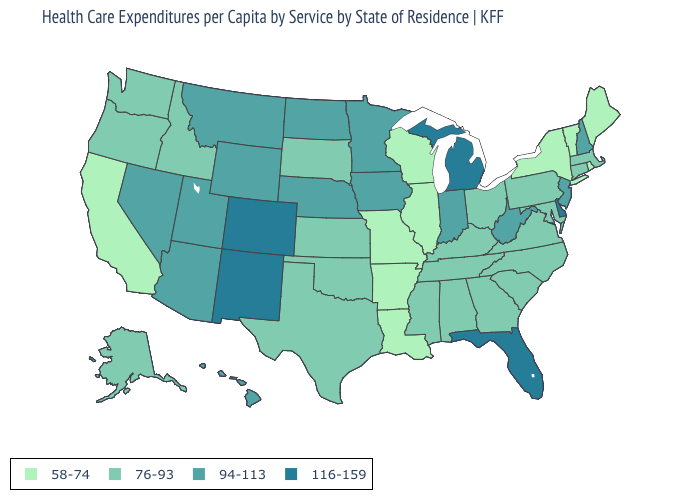Does the map have missing data?
Give a very brief answer. No. Which states have the lowest value in the MidWest?
Short answer required. Illinois, Missouri, Wisconsin. Which states have the highest value in the USA?
Give a very brief answer. Colorado, Delaware, Florida, Michigan, New Mexico. Does New York have the same value as Vermont?
Concise answer only. Yes. Among the states that border Alabama , does Mississippi have the lowest value?
Be succinct. Yes. Name the states that have a value in the range 76-93?
Quick response, please. Alabama, Alaska, Connecticut, Georgia, Idaho, Kansas, Kentucky, Maryland, Massachusetts, Mississippi, North Carolina, Ohio, Oklahoma, Oregon, Pennsylvania, South Carolina, South Dakota, Tennessee, Texas, Virginia, Washington. What is the highest value in the USA?
Short answer required. 116-159. What is the lowest value in the West?
Give a very brief answer. 58-74. What is the highest value in the USA?
Short answer required. 116-159. Name the states that have a value in the range 94-113?
Be succinct. Arizona, Hawaii, Indiana, Iowa, Minnesota, Montana, Nebraska, Nevada, New Hampshire, New Jersey, North Dakota, Utah, West Virginia, Wyoming. Name the states that have a value in the range 58-74?
Short answer required. Arkansas, California, Illinois, Louisiana, Maine, Missouri, New York, Rhode Island, Vermont, Wisconsin. What is the value of Maine?
Concise answer only. 58-74. What is the lowest value in the South?
Short answer required. 58-74. Name the states that have a value in the range 58-74?
Answer briefly. Arkansas, California, Illinois, Louisiana, Maine, Missouri, New York, Rhode Island, Vermont, Wisconsin. What is the highest value in the USA?
Answer briefly. 116-159. 